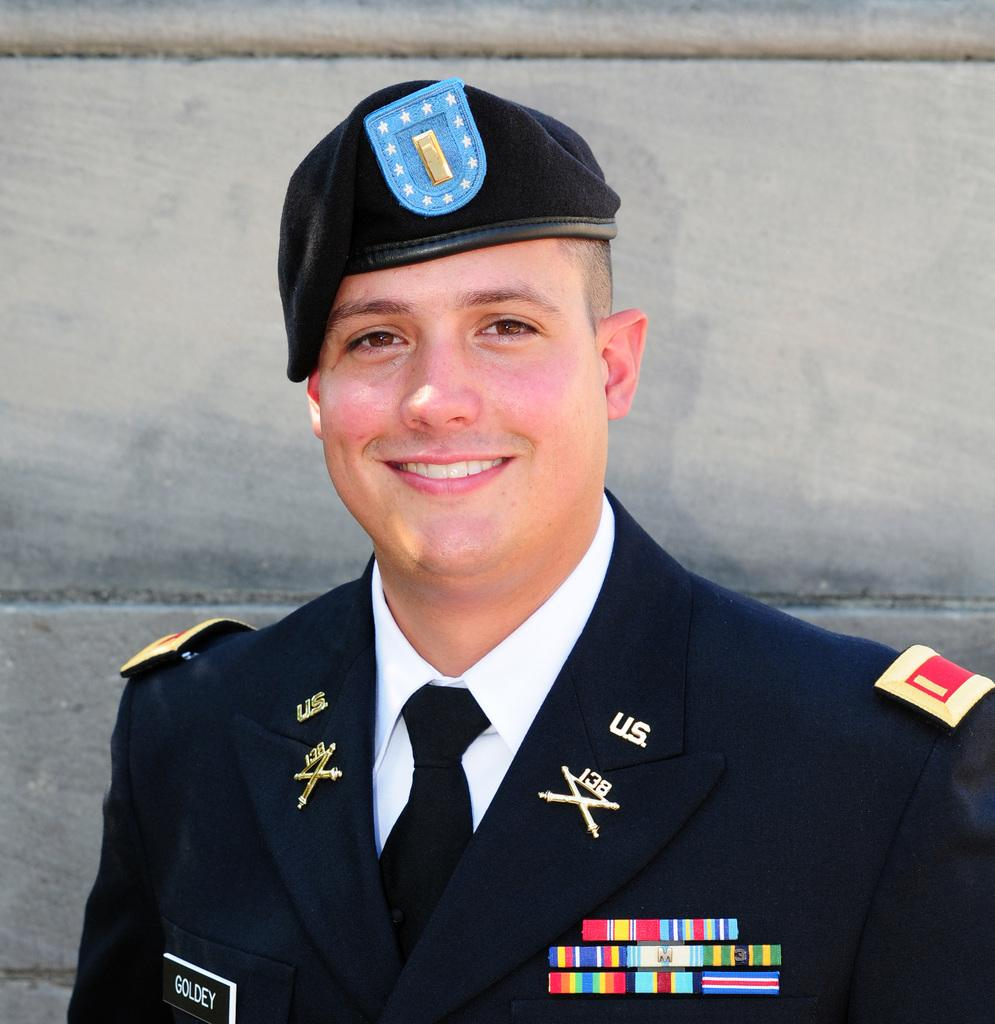Who or what is the main subject in the image? There is a person in the image. What is the person wearing? The person is wearing a uniform. What colors are present in the uniform? The uniform has blue and white colors. What can be seen in the background of the image? The background of the image includes a wall. What color is the wall in the image? The wall is in gray color. What type of rhythm can be heard in the image? There is no sound or music present in the image, so we cannot determine any rhythm. 